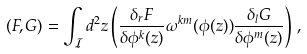<formula> <loc_0><loc_0><loc_500><loc_500>( F , G ) = \int _ { \mathcal { I } } d ^ { 2 } z \left ( \frac { \delta _ { r } F } { \delta \phi ^ { k } ( z ) } \omega ^ { k m } ( \phi ( z ) ) \frac { \delta _ { l } G } { \delta \phi ^ { m } ( z ) } \right ) \, ,</formula> 